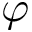<formula> <loc_0><loc_0><loc_500><loc_500>\varphi</formula> 